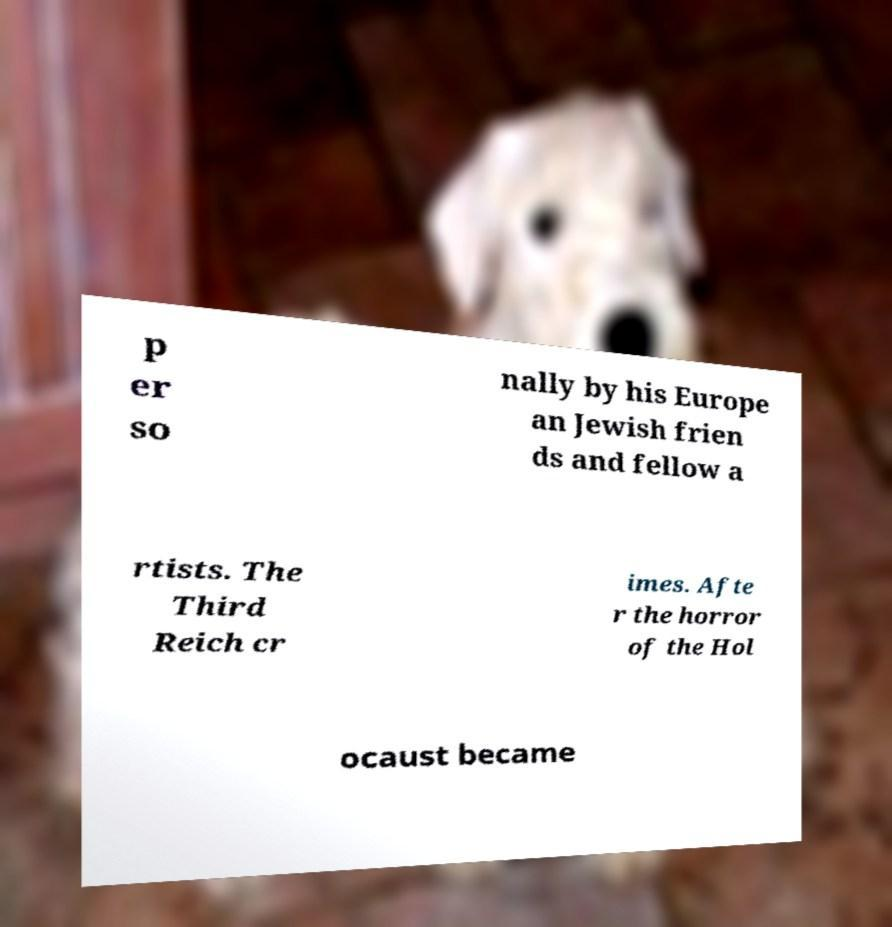For documentation purposes, I need the text within this image transcribed. Could you provide that? p er so nally by his Europe an Jewish frien ds and fellow a rtists. The Third Reich cr imes. Afte r the horror of the Hol ocaust became 